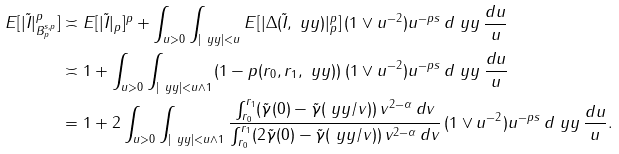<formula> <loc_0><loc_0><loc_500><loc_500>E [ | \tilde { I } | _ { B _ { p } ^ { s , p } } ^ { p } ] & \asymp E [ | \tilde { I } | _ { p } ] ^ { p } + \int _ { u > 0 } \int _ { | \ y y | < u } E [ | \Delta ( \tilde { I } , \ y y ) | _ { p } ^ { p } ] \, ( 1 \vee u ^ { - 2 } ) u ^ { - p { s } } \, d \ y y \, \frac { d u } { u } \\ & \asymp 1 + \int _ { u > 0 } \int _ { | \ y y | < u \wedge 1 } ( 1 - p ( r _ { 0 } , r _ { 1 } , \ y y ) ) \, ( 1 \vee u ^ { - 2 } ) u ^ { - p { s } } \, d \ y y \, \frac { d u } { u } \\ & = 1 + 2 \int _ { u > 0 } \int _ { | \ y y | < u \wedge 1 } \frac { \int _ { r _ { 0 } } ^ { r _ { 1 } } ( \tilde { \gamma } ( 0 ) - \tilde { \gamma } ( \ y y / v ) ) \, v ^ { 2 - \alpha } \, d v } { \int _ { r _ { 0 } } ^ { r _ { 1 } } ( 2 \tilde { \gamma } ( 0 ) - \tilde { \gamma } ( \ y y / v ) ) \, v ^ { 2 - \alpha } \, d v } \, ( 1 \vee u ^ { - 2 } ) u ^ { - p { s } } \, d \ y y \, \frac { d u } { u } .</formula> 